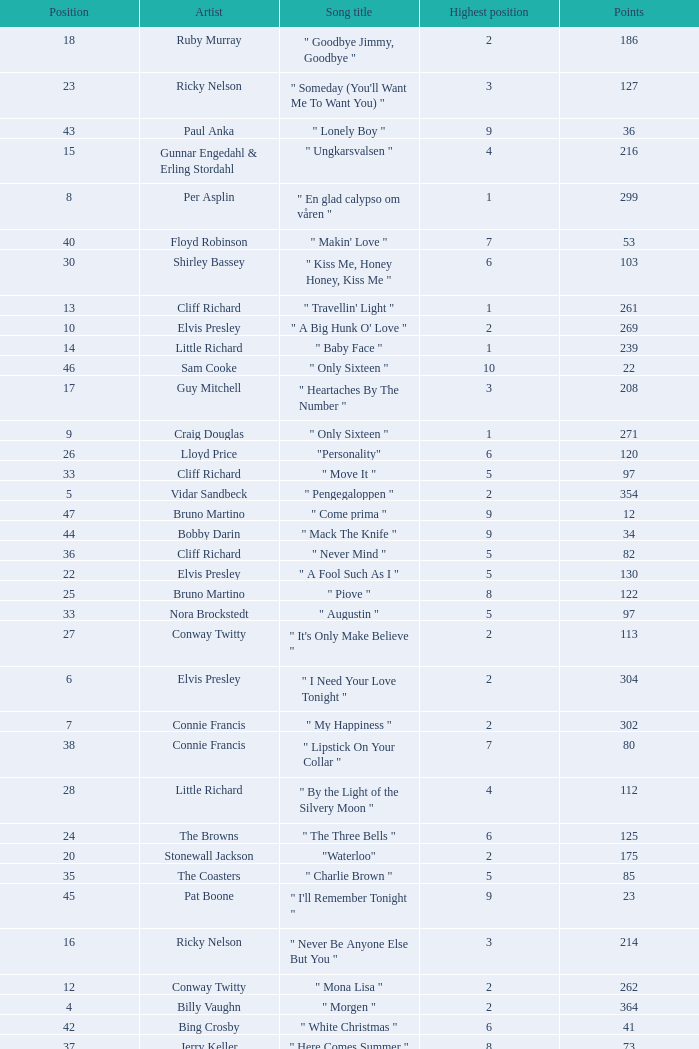What is the nme of the song performed by billy vaughn? " Morgen ". 